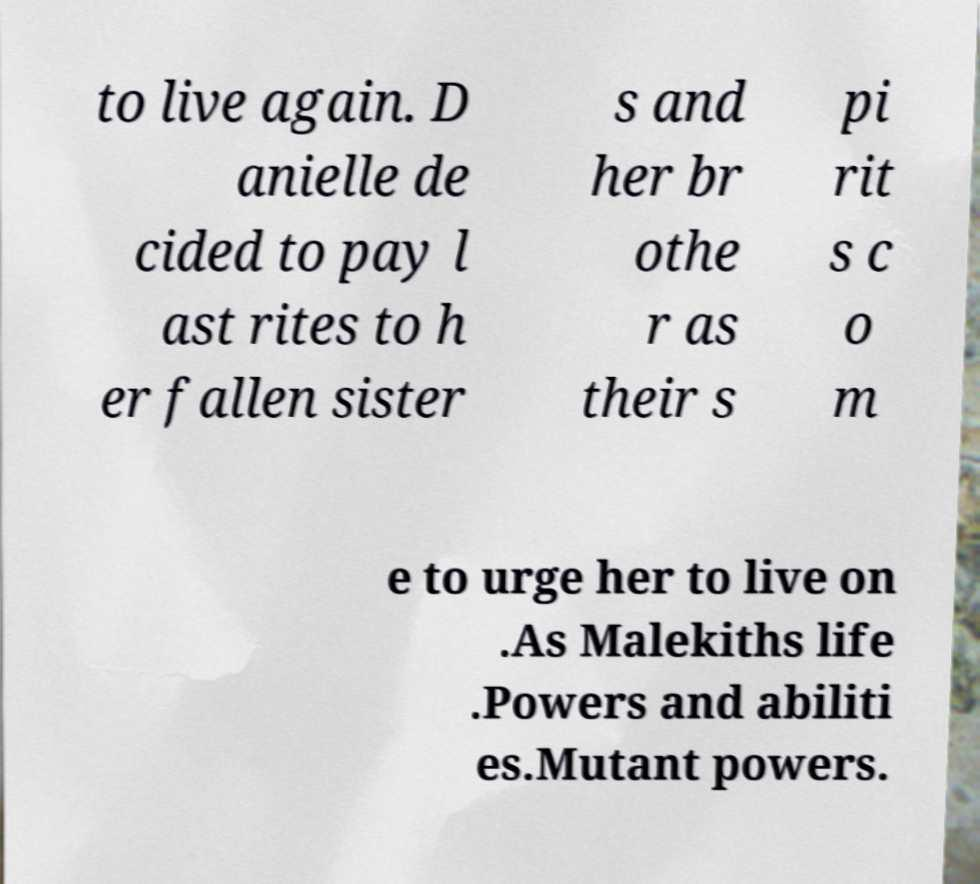What messages or text are displayed in this image? I need them in a readable, typed format. to live again. D anielle de cided to pay l ast rites to h er fallen sister s and her br othe r as their s pi rit s c o m e to urge her to live on .As Malekiths life .Powers and abiliti es.Mutant powers. 